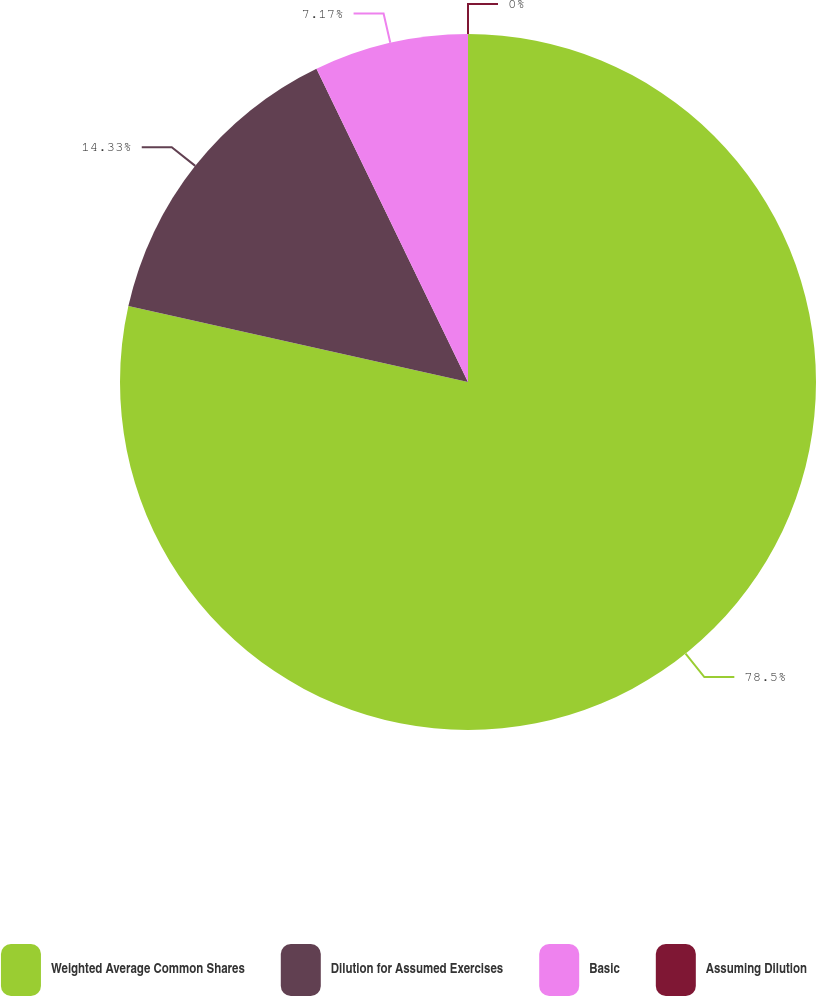<chart> <loc_0><loc_0><loc_500><loc_500><pie_chart><fcel>Weighted Average Common Shares<fcel>Dilution for Assumed Exercises<fcel>Basic<fcel>Assuming Dilution<nl><fcel>78.5%<fcel>14.33%<fcel>7.17%<fcel>0.0%<nl></chart> 